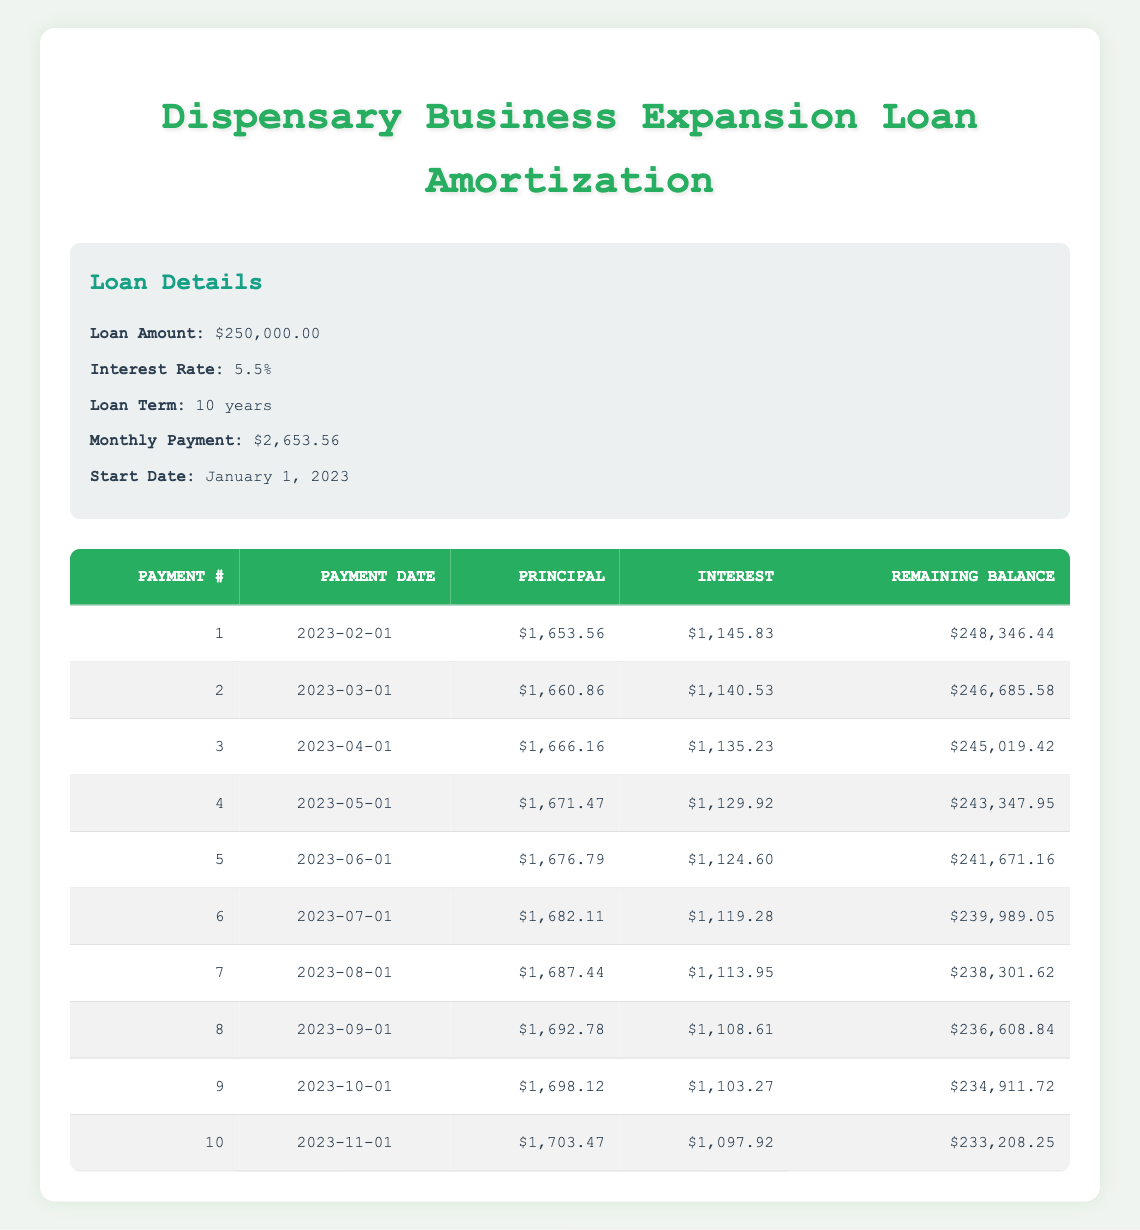What is the monthly payment for the loan? The monthly payment is directly provided in the loan details section. It shows that the monthly payment is $2,653.56.
Answer: 2,653.56 What is the amount of principal paid in the fourth payment? The record for the fourth payment includes a principal payment value of $1,671.47.
Answer: 1,671.47 True or False: The interest payment decreases with each payment made. Looking at the table, the interest payment starts at $1,145.83 and decreases gradually with each payment, confirming this observation.
Answer: True What is the total principal paid after the first three payments? Adding the principal payments from the first three payments gives us ($1,653.56 + $1,660.86 + $1,666.16 = $5,980.58). Therefore, the total principal paid after the first three payments is $5,980.58.
Answer: 5,980.58 What is the remaining balance after the fifth payment? The fifth payment's record lists a remaining balance of $241,671.16, which indicates how much is owed after this payment is made.
Answer: 241,671.16 How much more is paid in interest during the second payment than the first? The interest payment for the first payment is $1,145.83, and for the second payment, it is $1,140.53. The difference is $1,145.83 - $1,140.53 = $5.30, indicating that less interest was paid in the second payment compared to the first.
Answer: 5.30 What is the average principal payment made during the first ten payments? The total principal payment for the first ten payments needs to be calculated and then divided by ten. Adding the principal payments yields $16,763.66, which when divided by 10 gives an average of $1,676.37.
Answer: 1,676.37 After how many payments will the loan remaining balance go below $240,000? Examining the table, the remaining balance goes below $240,000 after the fifth payment, where it has decreased to $241,671.16. This implies it will fall below that threshold after the next payment.
Answer: 5 